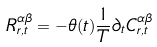<formula> <loc_0><loc_0><loc_500><loc_500>R ^ { \alpha \beta } _ { r , t } = - \theta ( t ) \frac { 1 } { T } \partial _ { t } C ^ { \alpha \beta } _ { r , t }</formula> 